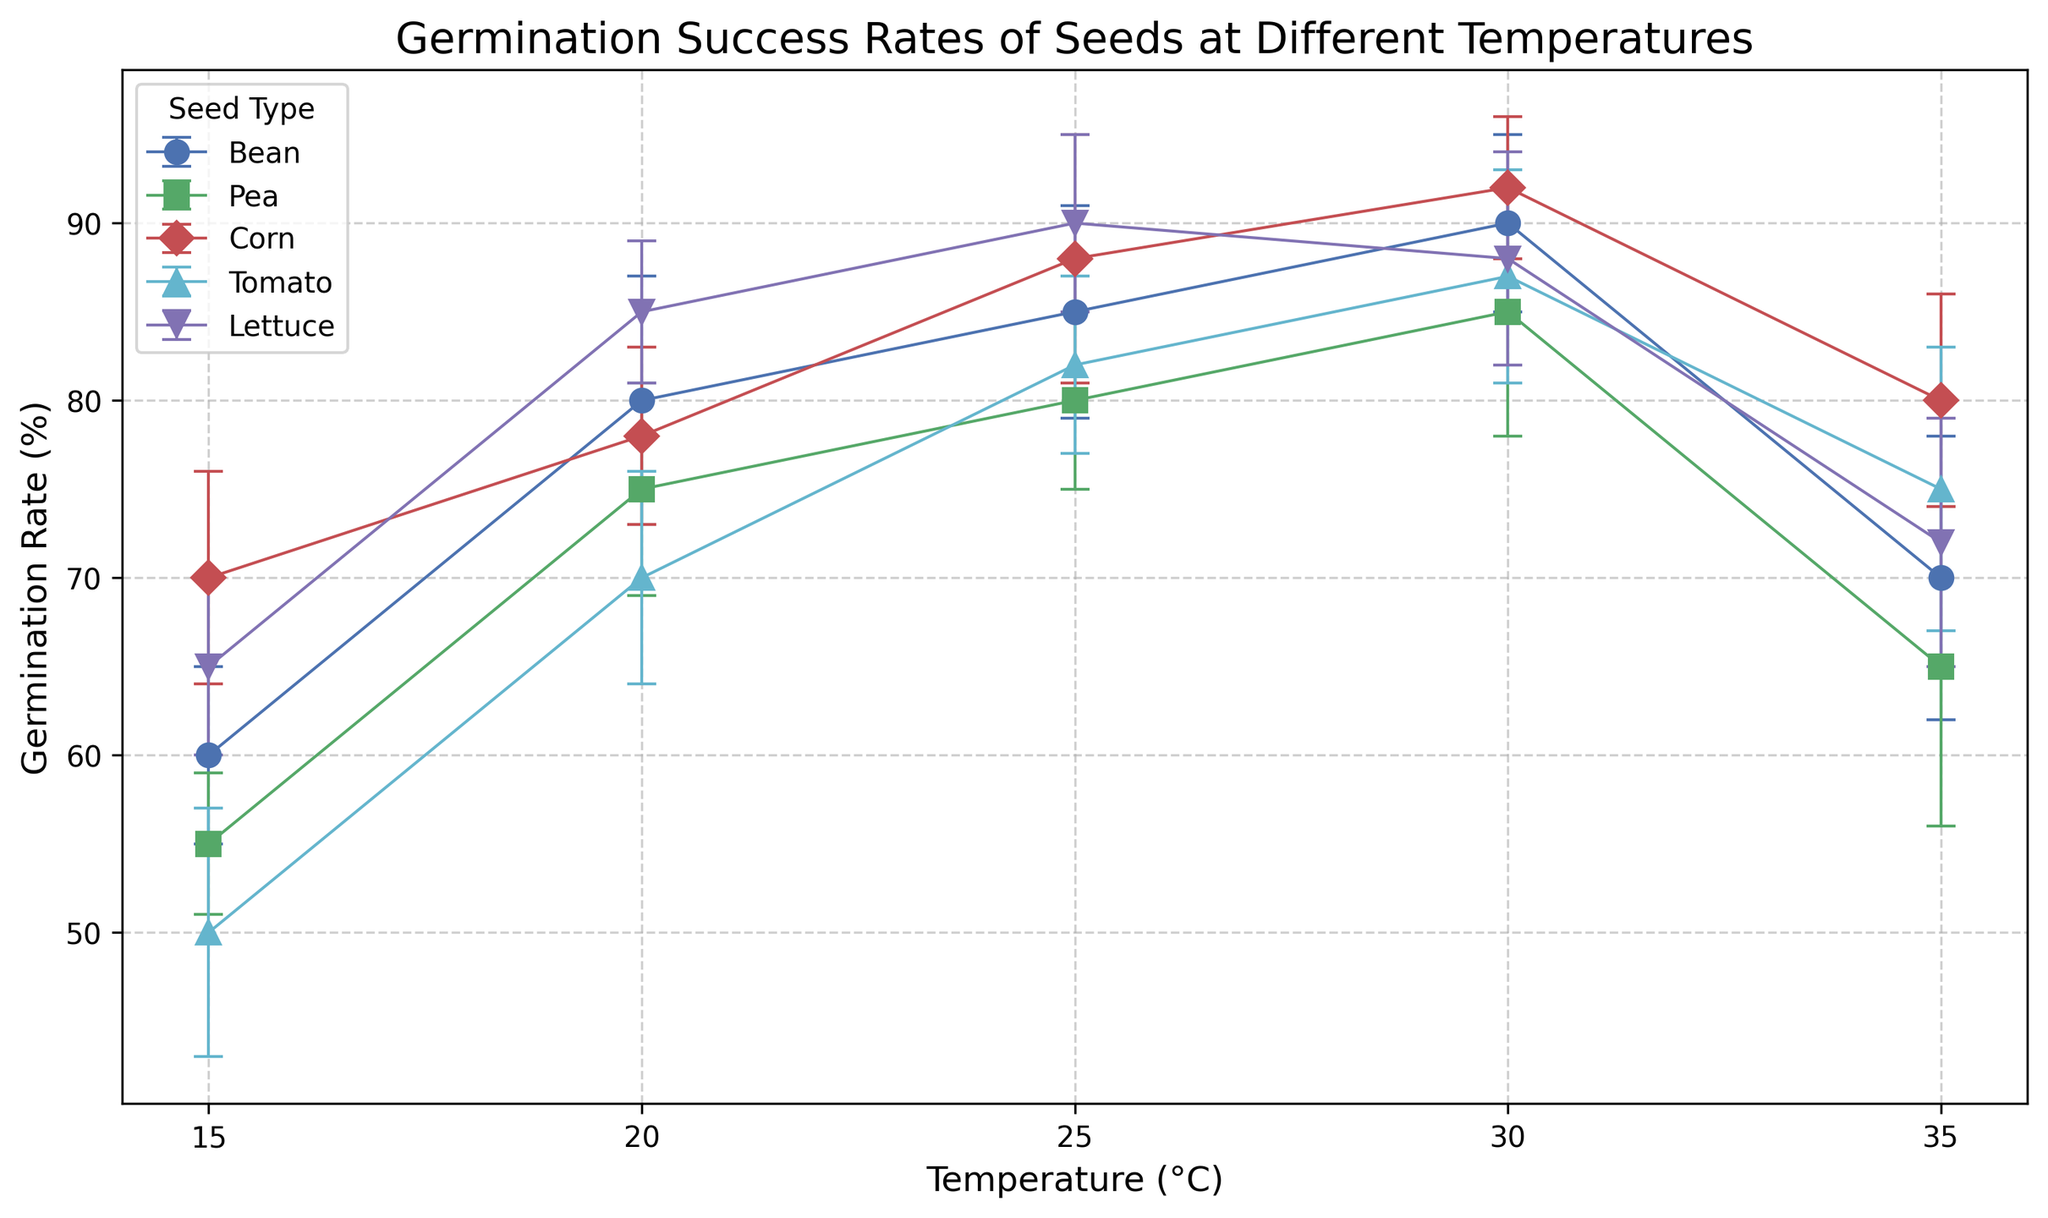What's the germination rate of Beans at 30°C? To find the germination rate of Beans at 30°C, look at the point labeled 30°C on the x-axis under the Beans' line. The y-value at this point shows the germination rate.
Answer: 90% Which seed type has the highest germination rate at 25°C? Compare the germination rates of all seed types at 25°C by looking at the points on the figure where the x-axis is 25°C. The highest y-value among these points represents the seed type with the highest germination rate.
Answer: Lettuce At 20°C, which seed type has a lower germination rate: Corn or Tomatoes? Check the germination rates for Corn and Tomatoes at 20°C by finding the corresponding y-values for each seed type. Compare the two values to determine which is lower.
Answer: Tomatoes Which seed type shows the greatest drop in germination rate from 30°C to 35°C? To determine the greatest drop, calculate the difference in germination rates from 30°C to 35°C for each seed type. Find the maximum difference value from these calculations.
Answer: Tomatoes Which temperature condition shows the highest average germination rate for all seed types combined? Calculate the average germination rate at each temperature by summing the individual rates for all seed types and dividing by the number of seed types (5). Compare these average rates to find the highest one.
Answer: 30°C What is the germination rate range (difference between maximum and minimum) for Peas across the temperature conditions? Identify the maximum and minimum germination rates for Peas across all temperature conditions, then subtract the minimum rate from the maximum rate.
Answer: 85 - 55 = 30% At which temperature do Beans and Corn have the same germination rate? Find the points where the germination rates (y-values) of Beans and Corn match, and note the corresponding temperature (x-axis).
Answer: 30°C What is the average germination rate of Lettuce at 15°C, 20°C, and 25°C? Sum the germination rates of Lettuce at 15°C, 20°C, and 25°C, then divide by the number of temperatures (3) to find the average.
Answer: (65 + 85 + 90) / 3 = 80% Which seed type exhibits the smallest standard deviation in germination rates at 20°C? Check the standard deviations for each seed type at 20°C by examining the error bars or provided data. The smallest value among these is the answer.
Answer: Lettuce How does the germination rate of Peas at 25°C compare to that of Corn at 15°C? Find the germination rates of Peas at 25°C and Corn at 15°C, then compare the two rates directly.
Answer: Peas at 25°C is higher 